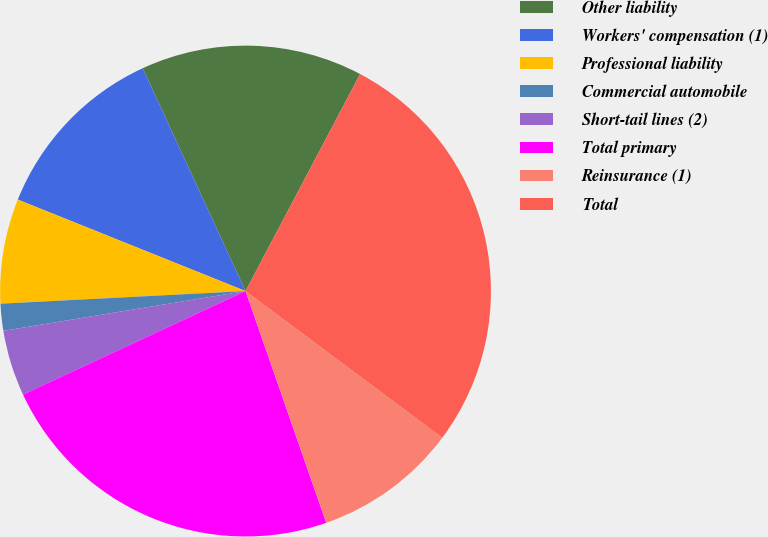Convert chart. <chart><loc_0><loc_0><loc_500><loc_500><pie_chart><fcel>Other liability<fcel>Workers' compensation (1)<fcel>Professional liability<fcel>Commercial automobile<fcel>Short-tail lines (2)<fcel>Total primary<fcel>Reinsurance (1)<fcel>Total<nl><fcel>14.61%<fcel>12.04%<fcel>6.9%<fcel>1.77%<fcel>4.34%<fcel>23.4%<fcel>9.47%<fcel>27.46%<nl></chart> 